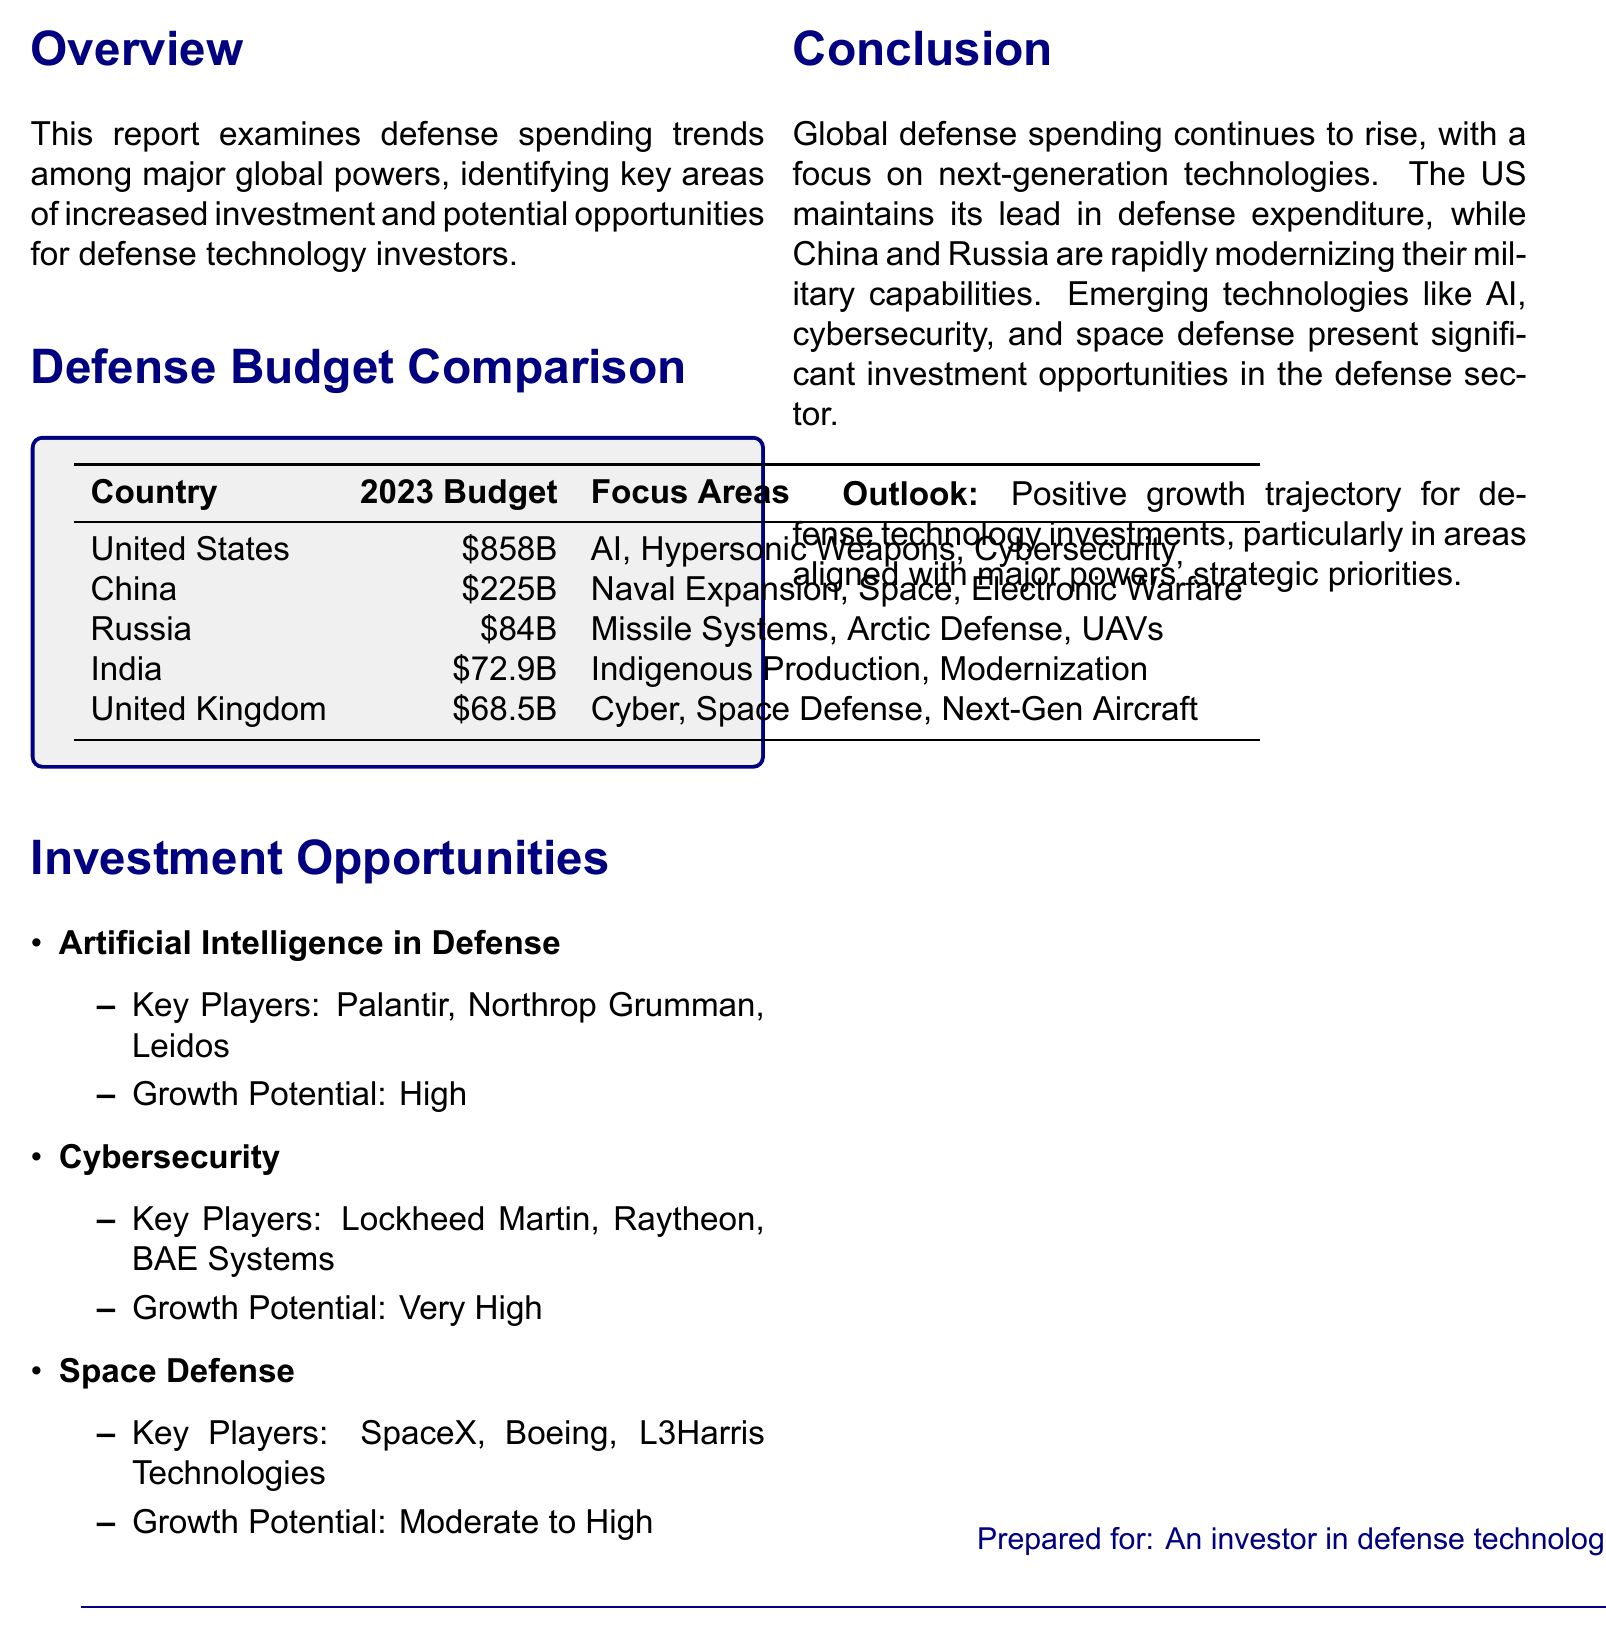What is the defense budget of the United States for 2023? The document specifies that the defense budget of the United States for 2023 is $858 billion.
Answer: $858 billion Which country has the lowest defense budget? According to the document, Russia has the lowest defense budget in 2023, at $84 billion.
Answer: $84 billion What are the focus areas for India's defense budget? The document lists the focus areas for India's defense budget as Indigenous Production, Modernization, and Border Infrastructure.
Answer: Indigenous Production, Modernization, Border Infrastructure Which sector has the highest growth potential for investment? The document indicates Cybersecurity has the highest growth potential for investment, categorized as Very High.
Answer: Very High What is the primary focus area for China's defense budget? The document states that China focuses on Naval Expansion, Space Capabilities, and Electronic Warfare in its defense budget.
Answer: Naval Expansion, Space Capabilities, Electronic Warfare Which country focuses on Next-Gen Aircraft in its defense spending? The document identifies the United Kingdom as focusing on Next-Gen Aircraft in its defense spending.
Answer: United Kingdom What is the projected outlook for defense technology investments? The document concludes that the outlook for defense technology investments is a Positive growth trajectory.
Answer: Positive growth trajectory Which company is listed as a key player in Artificial Intelligence in Defense? The document lists Palantir Technologies as a key player in Artificial Intelligence in Defense.
Answer: Palantir Technologies What is the title of the report? The title of the report is "Comparative Analysis of Defense Budgets: Major World Powers."
Answer: Comparative Analysis of Defense Budgets: Major World Powers 